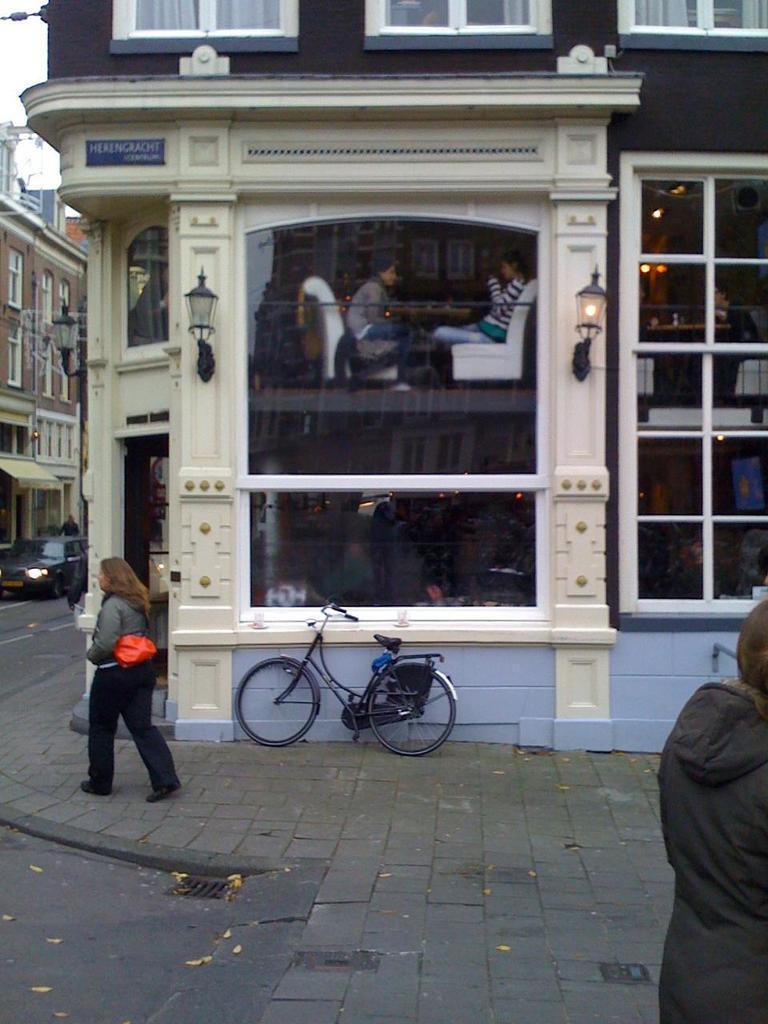Can you describe this image briefly? In this image we can see road. There are people walking. There is a bicycle. In the background of the image there are buildings, windows. There is a car. In the center of the image there are two people sitting on chairs through glass windows. 